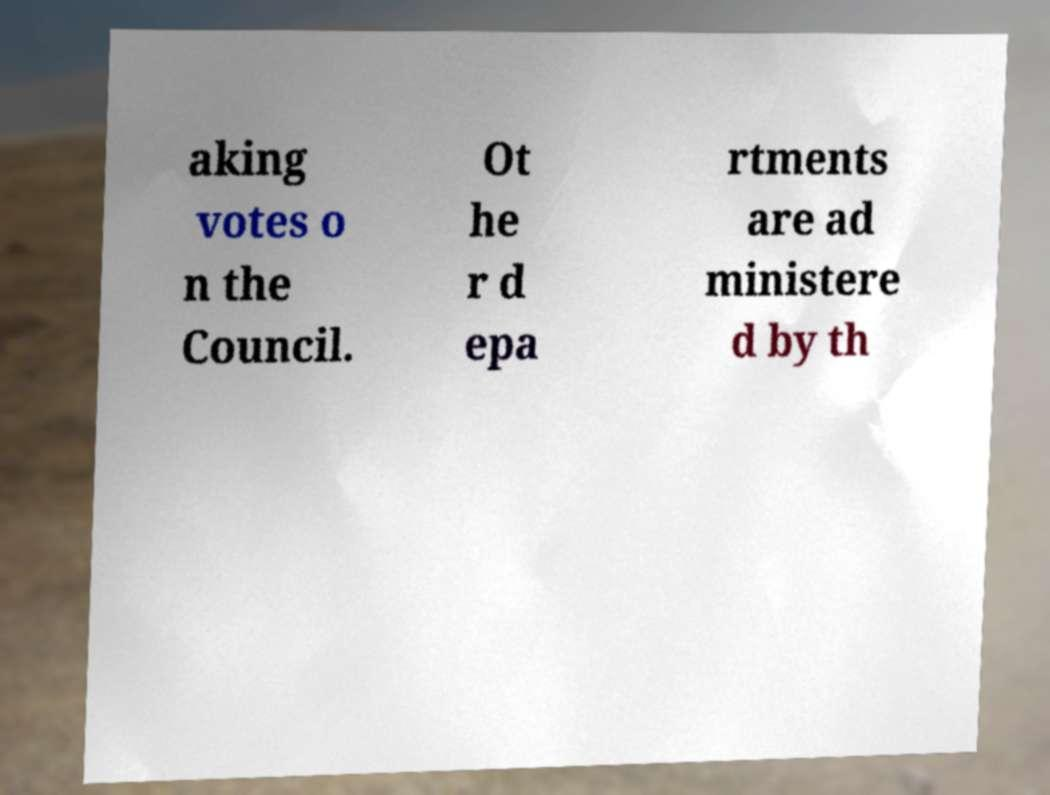There's text embedded in this image that I need extracted. Can you transcribe it verbatim? aking votes o n the Council. Ot he r d epa rtments are ad ministere d by th 